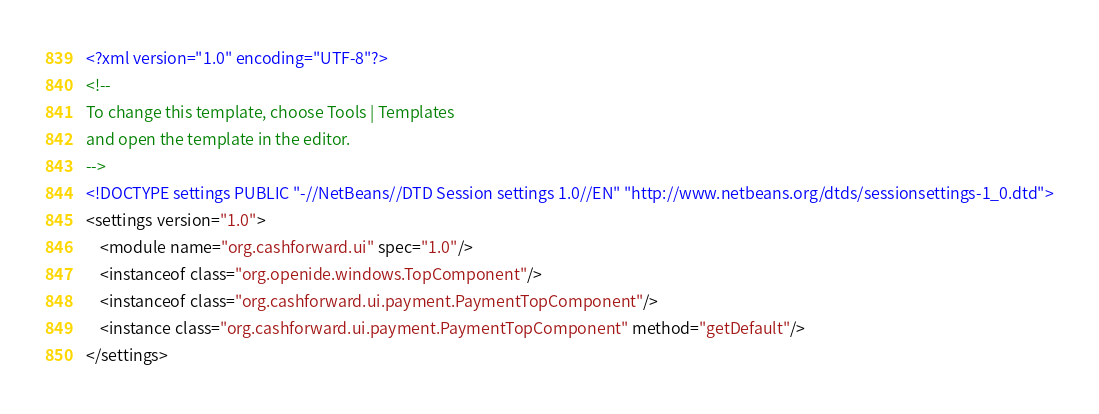Convert code to text. <code><loc_0><loc_0><loc_500><loc_500><_XML_><?xml version="1.0" encoding="UTF-8"?>
<!--
To change this template, choose Tools | Templates
and open the template in the editor.
-->
<!DOCTYPE settings PUBLIC "-//NetBeans//DTD Session settings 1.0//EN" "http://www.netbeans.org/dtds/sessionsettings-1_0.dtd">
<settings version="1.0">
    <module name="org.cashforward.ui" spec="1.0"/>
    <instanceof class="org.openide.windows.TopComponent"/>
    <instanceof class="org.cashforward.ui.payment.PaymentTopComponent"/>
    <instance class="org.cashforward.ui.payment.PaymentTopComponent" method="getDefault"/>
</settings>
</code> 